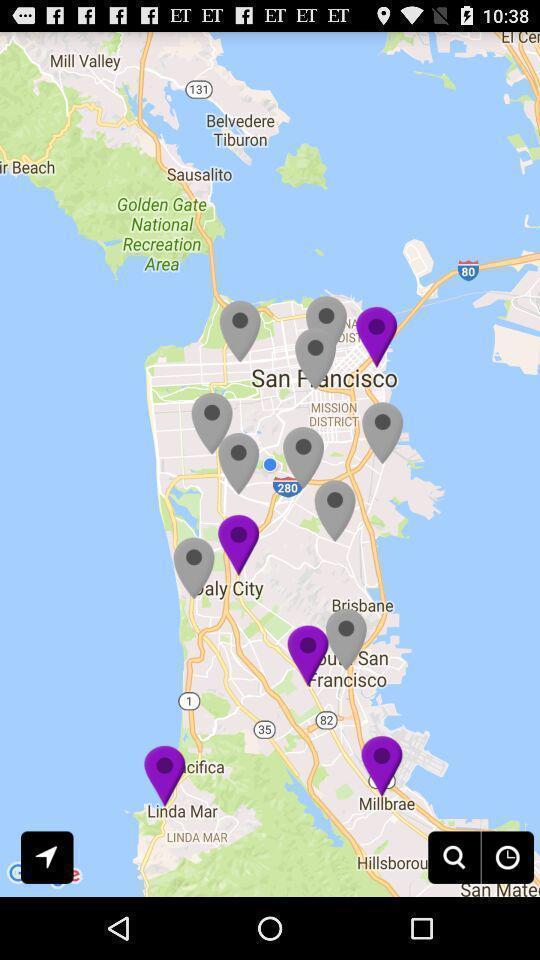What details can you identify in this image? Various locations displayed in map navigation app. 